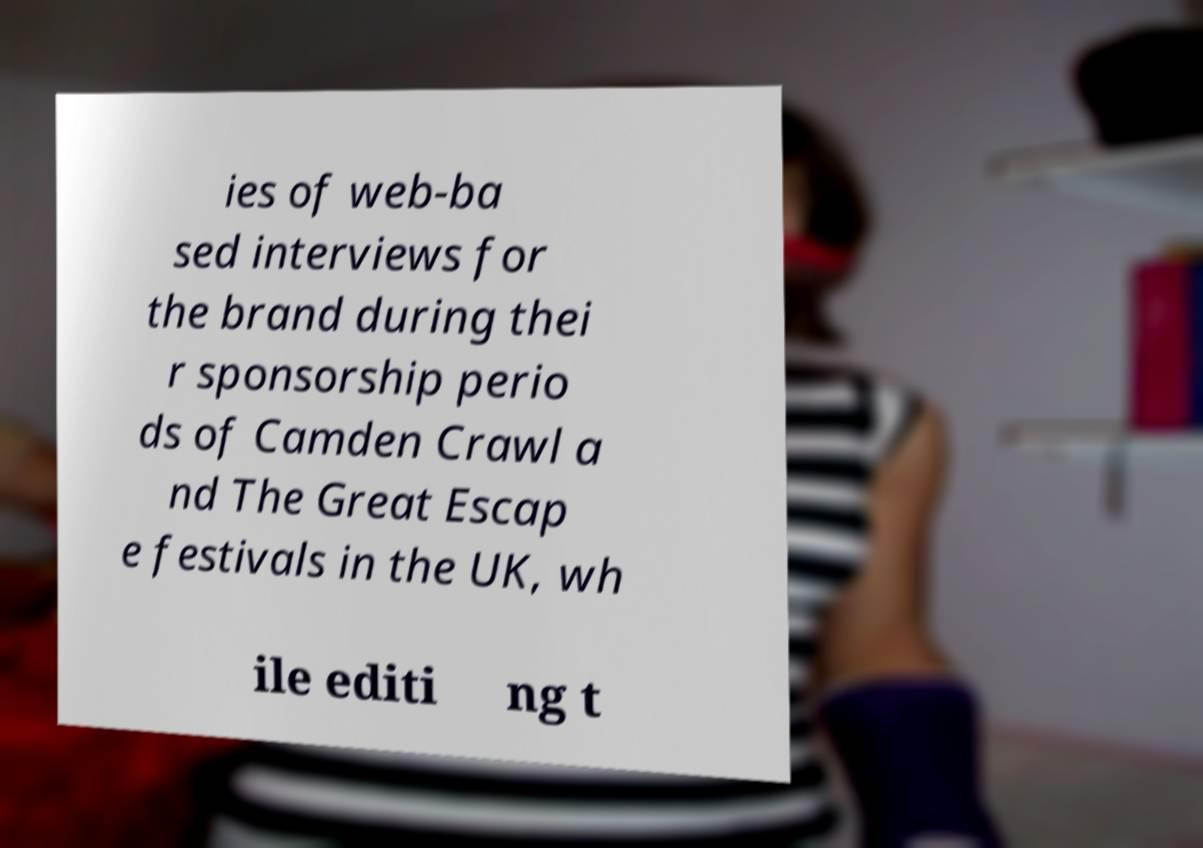For documentation purposes, I need the text within this image transcribed. Could you provide that? ies of web-ba sed interviews for the brand during thei r sponsorship perio ds of Camden Crawl a nd The Great Escap e festivals in the UK, wh ile editi ng t 